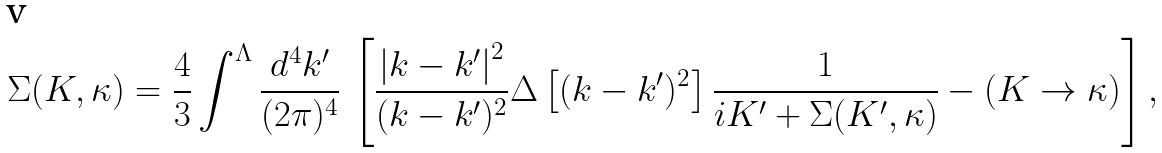<formula> <loc_0><loc_0><loc_500><loc_500>\Sigma ( K , \kappa ) = \frac { 4 } { 3 } \int ^ { \Lambda } \frac { d ^ { 4 } k ^ { \prime } } { ( 2 \pi ) ^ { 4 } } \, \left [ \frac { \left | { k } - { k } ^ { \prime } \right | ^ { 2 } } { ( k - k ^ { \prime } ) ^ { 2 } } \Delta \left [ ( k - k ^ { \prime } ) ^ { 2 } \right ] \frac { 1 } { i K ^ { \prime } + \Sigma ( K ^ { \prime } , \kappa ) } - ( K \rightarrow \kappa ) \right ] ,</formula> 